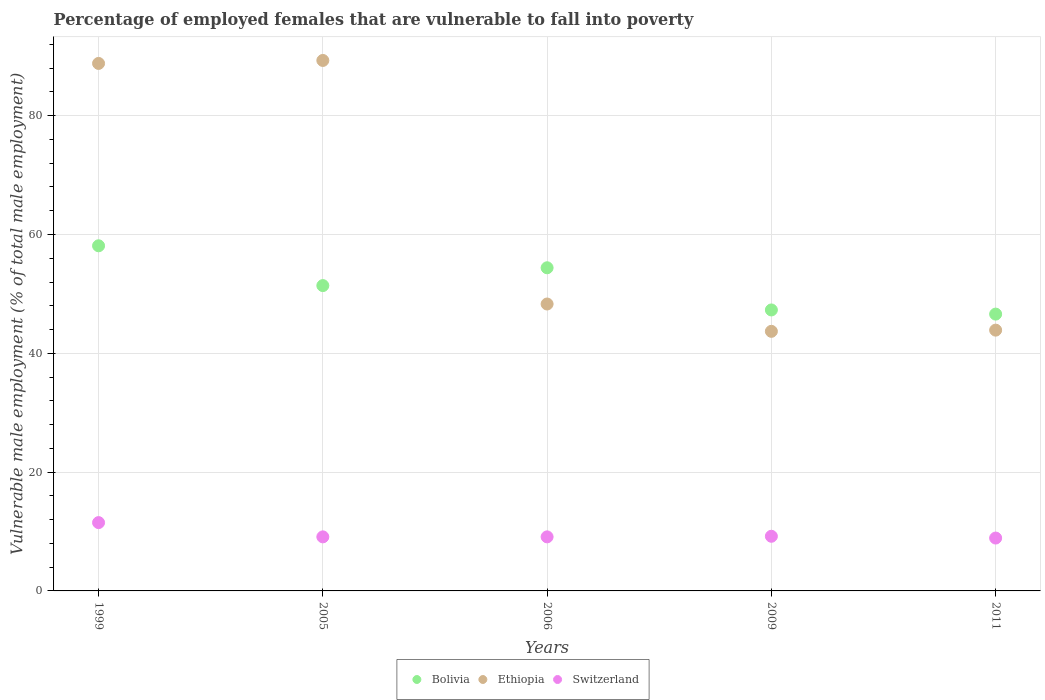What is the percentage of employed females who are vulnerable to fall into poverty in Bolivia in 1999?
Provide a short and direct response. 58.1. Across all years, what is the minimum percentage of employed females who are vulnerable to fall into poverty in Bolivia?
Your response must be concise. 46.6. What is the total percentage of employed females who are vulnerable to fall into poverty in Ethiopia in the graph?
Keep it short and to the point. 314. What is the difference between the percentage of employed females who are vulnerable to fall into poverty in Bolivia in 2005 and that in 2009?
Provide a short and direct response. 4.1. What is the difference between the percentage of employed females who are vulnerable to fall into poverty in Switzerland in 2006 and the percentage of employed females who are vulnerable to fall into poverty in Ethiopia in 2011?
Make the answer very short. -34.8. What is the average percentage of employed females who are vulnerable to fall into poverty in Bolivia per year?
Ensure brevity in your answer.  51.56. In the year 2005, what is the difference between the percentage of employed females who are vulnerable to fall into poverty in Bolivia and percentage of employed females who are vulnerable to fall into poverty in Ethiopia?
Make the answer very short. -37.9. What is the ratio of the percentage of employed females who are vulnerable to fall into poverty in Ethiopia in 1999 to that in 2005?
Your answer should be very brief. 0.99. Is the percentage of employed females who are vulnerable to fall into poverty in Ethiopia in 2005 less than that in 2009?
Provide a short and direct response. No. Is the difference between the percentage of employed females who are vulnerable to fall into poverty in Bolivia in 2006 and 2009 greater than the difference between the percentage of employed females who are vulnerable to fall into poverty in Ethiopia in 2006 and 2009?
Ensure brevity in your answer.  Yes. What is the difference between the highest and the second highest percentage of employed females who are vulnerable to fall into poverty in Bolivia?
Give a very brief answer. 3.7. What is the difference between the highest and the lowest percentage of employed females who are vulnerable to fall into poverty in Switzerland?
Provide a succinct answer. 2.6. How many dotlines are there?
Offer a very short reply. 3. How many years are there in the graph?
Provide a succinct answer. 5. Are the values on the major ticks of Y-axis written in scientific E-notation?
Your answer should be very brief. No. Does the graph contain any zero values?
Keep it short and to the point. No. What is the title of the graph?
Your response must be concise. Percentage of employed females that are vulnerable to fall into poverty. Does "Ethiopia" appear as one of the legend labels in the graph?
Keep it short and to the point. Yes. What is the label or title of the Y-axis?
Offer a very short reply. Vulnerable male employment (% of total male employment). What is the Vulnerable male employment (% of total male employment) of Bolivia in 1999?
Ensure brevity in your answer.  58.1. What is the Vulnerable male employment (% of total male employment) in Ethiopia in 1999?
Provide a succinct answer. 88.8. What is the Vulnerable male employment (% of total male employment) in Bolivia in 2005?
Keep it short and to the point. 51.4. What is the Vulnerable male employment (% of total male employment) in Ethiopia in 2005?
Your answer should be very brief. 89.3. What is the Vulnerable male employment (% of total male employment) of Switzerland in 2005?
Your answer should be compact. 9.1. What is the Vulnerable male employment (% of total male employment) in Bolivia in 2006?
Offer a very short reply. 54.4. What is the Vulnerable male employment (% of total male employment) in Ethiopia in 2006?
Your response must be concise. 48.3. What is the Vulnerable male employment (% of total male employment) of Switzerland in 2006?
Keep it short and to the point. 9.1. What is the Vulnerable male employment (% of total male employment) of Bolivia in 2009?
Make the answer very short. 47.3. What is the Vulnerable male employment (% of total male employment) of Ethiopia in 2009?
Offer a very short reply. 43.7. What is the Vulnerable male employment (% of total male employment) of Switzerland in 2009?
Make the answer very short. 9.2. What is the Vulnerable male employment (% of total male employment) in Bolivia in 2011?
Offer a terse response. 46.6. What is the Vulnerable male employment (% of total male employment) of Ethiopia in 2011?
Offer a very short reply. 43.9. What is the Vulnerable male employment (% of total male employment) in Switzerland in 2011?
Offer a very short reply. 8.9. Across all years, what is the maximum Vulnerable male employment (% of total male employment) in Bolivia?
Provide a short and direct response. 58.1. Across all years, what is the maximum Vulnerable male employment (% of total male employment) in Ethiopia?
Your response must be concise. 89.3. Across all years, what is the maximum Vulnerable male employment (% of total male employment) in Switzerland?
Keep it short and to the point. 11.5. Across all years, what is the minimum Vulnerable male employment (% of total male employment) of Bolivia?
Provide a succinct answer. 46.6. Across all years, what is the minimum Vulnerable male employment (% of total male employment) in Ethiopia?
Make the answer very short. 43.7. Across all years, what is the minimum Vulnerable male employment (% of total male employment) in Switzerland?
Provide a succinct answer. 8.9. What is the total Vulnerable male employment (% of total male employment) of Bolivia in the graph?
Your answer should be compact. 257.8. What is the total Vulnerable male employment (% of total male employment) in Ethiopia in the graph?
Make the answer very short. 314. What is the total Vulnerable male employment (% of total male employment) of Switzerland in the graph?
Give a very brief answer. 47.8. What is the difference between the Vulnerable male employment (% of total male employment) of Ethiopia in 1999 and that in 2006?
Keep it short and to the point. 40.5. What is the difference between the Vulnerable male employment (% of total male employment) in Ethiopia in 1999 and that in 2009?
Your answer should be compact. 45.1. What is the difference between the Vulnerable male employment (% of total male employment) of Bolivia in 1999 and that in 2011?
Your response must be concise. 11.5. What is the difference between the Vulnerable male employment (% of total male employment) of Ethiopia in 1999 and that in 2011?
Make the answer very short. 44.9. What is the difference between the Vulnerable male employment (% of total male employment) in Switzerland in 1999 and that in 2011?
Give a very brief answer. 2.6. What is the difference between the Vulnerable male employment (% of total male employment) in Ethiopia in 2005 and that in 2006?
Keep it short and to the point. 41. What is the difference between the Vulnerable male employment (% of total male employment) of Bolivia in 2005 and that in 2009?
Your response must be concise. 4.1. What is the difference between the Vulnerable male employment (% of total male employment) of Ethiopia in 2005 and that in 2009?
Your answer should be very brief. 45.6. What is the difference between the Vulnerable male employment (% of total male employment) in Switzerland in 2005 and that in 2009?
Provide a succinct answer. -0.1. What is the difference between the Vulnerable male employment (% of total male employment) of Ethiopia in 2005 and that in 2011?
Your response must be concise. 45.4. What is the difference between the Vulnerable male employment (% of total male employment) in Switzerland in 2005 and that in 2011?
Offer a very short reply. 0.2. What is the difference between the Vulnerable male employment (% of total male employment) in Bolivia in 2006 and that in 2009?
Make the answer very short. 7.1. What is the difference between the Vulnerable male employment (% of total male employment) in Ethiopia in 2006 and that in 2009?
Provide a succinct answer. 4.6. What is the difference between the Vulnerable male employment (% of total male employment) of Ethiopia in 2006 and that in 2011?
Make the answer very short. 4.4. What is the difference between the Vulnerable male employment (% of total male employment) in Bolivia in 2009 and that in 2011?
Offer a terse response. 0.7. What is the difference between the Vulnerable male employment (% of total male employment) of Switzerland in 2009 and that in 2011?
Give a very brief answer. 0.3. What is the difference between the Vulnerable male employment (% of total male employment) of Bolivia in 1999 and the Vulnerable male employment (% of total male employment) of Ethiopia in 2005?
Provide a short and direct response. -31.2. What is the difference between the Vulnerable male employment (% of total male employment) of Ethiopia in 1999 and the Vulnerable male employment (% of total male employment) of Switzerland in 2005?
Offer a very short reply. 79.7. What is the difference between the Vulnerable male employment (% of total male employment) in Ethiopia in 1999 and the Vulnerable male employment (% of total male employment) in Switzerland in 2006?
Give a very brief answer. 79.7. What is the difference between the Vulnerable male employment (% of total male employment) in Bolivia in 1999 and the Vulnerable male employment (% of total male employment) in Switzerland in 2009?
Give a very brief answer. 48.9. What is the difference between the Vulnerable male employment (% of total male employment) of Ethiopia in 1999 and the Vulnerable male employment (% of total male employment) of Switzerland in 2009?
Keep it short and to the point. 79.6. What is the difference between the Vulnerable male employment (% of total male employment) of Bolivia in 1999 and the Vulnerable male employment (% of total male employment) of Switzerland in 2011?
Offer a terse response. 49.2. What is the difference between the Vulnerable male employment (% of total male employment) in Ethiopia in 1999 and the Vulnerable male employment (% of total male employment) in Switzerland in 2011?
Keep it short and to the point. 79.9. What is the difference between the Vulnerable male employment (% of total male employment) of Bolivia in 2005 and the Vulnerable male employment (% of total male employment) of Switzerland in 2006?
Give a very brief answer. 42.3. What is the difference between the Vulnerable male employment (% of total male employment) of Ethiopia in 2005 and the Vulnerable male employment (% of total male employment) of Switzerland in 2006?
Your response must be concise. 80.2. What is the difference between the Vulnerable male employment (% of total male employment) in Bolivia in 2005 and the Vulnerable male employment (% of total male employment) in Ethiopia in 2009?
Keep it short and to the point. 7.7. What is the difference between the Vulnerable male employment (% of total male employment) of Bolivia in 2005 and the Vulnerable male employment (% of total male employment) of Switzerland in 2009?
Provide a short and direct response. 42.2. What is the difference between the Vulnerable male employment (% of total male employment) of Ethiopia in 2005 and the Vulnerable male employment (% of total male employment) of Switzerland in 2009?
Keep it short and to the point. 80.1. What is the difference between the Vulnerable male employment (% of total male employment) in Bolivia in 2005 and the Vulnerable male employment (% of total male employment) in Switzerland in 2011?
Your answer should be very brief. 42.5. What is the difference between the Vulnerable male employment (% of total male employment) in Ethiopia in 2005 and the Vulnerable male employment (% of total male employment) in Switzerland in 2011?
Offer a very short reply. 80.4. What is the difference between the Vulnerable male employment (% of total male employment) of Bolivia in 2006 and the Vulnerable male employment (% of total male employment) of Ethiopia in 2009?
Ensure brevity in your answer.  10.7. What is the difference between the Vulnerable male employment (% of total male employment) in Bolivia in 2006 and the Vulnerable male employment (% of total male employment) in Switzerland in 2009?
Give a very brief answer. 45.2. What is the difference between the Vulnerable male employment (% of total male employment) of Ethiopia in 2006 and the Vulnerable male employment (% of total male employment) of Switzerland in 2009?
Make the answer very short. 39.1. What is the difference between the Vulnerable male employment (% of total male employment) in Bolivia in 2006 and the Vulnerable male employment (% of total male employment) in Ethiopia in 2011?
Keep it short and to the point. 10.5. What is the difference between the Vulnerable male employment (% of total male employment) of Bolivia in 2006 and the Vulnerable male employment (% of total male employment) of Switzerland in 2011?
Make the answer very short. 45.5. What is the difference between the Vulnerable male employment (% of total male employment) in Ethiopia in 2006 and the Vulnerable male employment (% of total male employment) in Switzerland in 2011?
Offer a terse response. 39.4. What is the difference between the Vulnerable male employment (% of total male employment) in Bolivia in 2009 and the Vulnerable male employment (% of total male employment) in Switzerland in 2011?
Offer a terse response. 38.4. What is the difference between the Vulnerable male employment (% of total male employment) in Ethiopia in 2009 and the Vulnerable male employment (% of total male employment) in Switzerland in 2011?
Offer a very short reply. 34.8. What is the average Vulnerable male employment (% of total male employment) of Bolivia per year?
Provide a short and direct response. 51.56. What is the average Vulnerable male employment (% of total male employment) of Ethiopia per year?
Your answer should be compact. 62.8. What is the average Vulnerable male employment (% of total male employment) of Switzerland per year?
Provide a succinct answer. 9.56. In the year 1999, what is the difference between the Vulnerable male employment (% of total male employment) of Bolivia and Vulnerable male employment (% of total male employment) of Ethiopia?
Provide a succinct answer. -30.7. In the year 1999, what is the difference between the Vulnerable male employment (% of total male employment) of Bolivia and Vulnerable male employment (% of total male employment) of Switzerland?
Make the answer very short. 46.6. In the year 1999, what is the difference between the Vulnerable male employment (% of total male employment) of Ethiopia and Vulnerable male employment (% of total male employment) of Switzerland?
Your answer should be compact. 77.3. In the year 2005, what is the difference between the Vulnerable male employment (% of total male employment) of Bolivia and Vulnerable male employment (% of total male employment) of Ethiopia?
Offer a very short reply. -37.9. In the year 2005, what is the difference between the Vulnerable male employment (% of total male employment) in Bolivia and Vulnerable male employment (% of total male employment) in Switzerland?
Keep it short and to the point. 42.3. In the year 2005, what is the difference between the Vulnerable male employment (% of total male employment) in Ethiopia and Vulnerable male employment (% of total male employment) in Switzerland?
Give a very brief answer. 80.2. In the year 2006, what is the difference between the Vulnerable male employment (% of total male employment) of Bolivia and Vulnerable male employment (% of total male employment) of Ethiopia?
Offer a very short reply. 6.1. In the year 2006, what is the difference between the Vulnerable male employment (% of total male employment) in Bolivia and Vulnerable male employment (% of total male employment) in Switzerland?
Ensure brevity in your answer.  45.3. In the year 2006, what is the difference between the Vulnerable male employment (% of total male employment) of Ethiopia and Vulnerable male employment (% of total male employment) of Switzerland?
Give a very brief answer. 39.2. In the year 2009, what is the difference between the Vulnerable male employment (% of total male employment) of Bolivia and Vulnerable male employment (% of total male employment) of Switzerland?
Make the answer very short. 38.1. In the year 2009, what is the difference between the Vulnerable male employment (% of total male employment) of Ethiopia and Vulnerable male employment (% of total male employment) of Switzerland?
Provide a short and direct response. 34.5. In the year 2011, what is the difference between the Vulnerable male employment (% of total male employment) in Bolivia and Vulnerable male employment (% of total male employment) in Ethiopia?
Ensure brevity in your answer.  2.7. In the year 2011, what is the difference between the Vulnerable male employment (% of total male employment) in Bolivia and Vulnerable male employment (% of total male employment) in Switzerland?
Give a very brief answer. 37.7. In the year 2011, what is the difference between the Vulnerable male employment (% of total male employment) of Ethiopia and Vulnerable male employment (% of total male employment) of Switzerland?
Provide a short and direct response. 35. What is the ratio of the Vulnerable male employment (% of total male employment) in Bolivia in 1999 to that in 2005?
Give a very brief answer. 1.13. What is the ratio of the Vulnerable male employment (% of total male employment) of Ethiopia in 1999 to that in 2005?
Provide a short and direct response. 0.99. What is the ratio of the Vulnerable male employment (% of total male employment) in Switzerland in 1999 to that in 2005?
Make the answer very short. 1.26. What is the ratio of the Vulnerable male employment (% of total male employment) in Bolivia in 1999 to that in 2006?
Make the answer very short. 1.07. What is the ratio of the Vulnerable male employment (% of total male employment) in Ethiopia in 1999 to that in 2006?
Your response must be concise. 1.84. What is the ratio of the Vulnerable male employment (% of total male employment) of Switzerland in 1999 to that in 2006?
Give a very brief answer. 1.26. What is the ratio of the Vulnerable male employment (% of total male employment) of Bolivia in 1999 to that in 2009?
Ensure brevity in your answer.  1.23. What is the ratio of the Vulnerable male employment (% of total male employment) of Ethiopia in 1999 to that in 2009?
Keep it short and to the point. 2.03. What is the ratio of the Vulnerable male employment (% of total male employment) in Bolivia in 1999 to that in 2011?
Your response must be concise. 1.25. What is the ratio of the Vulnerable male employment (% of total male employment) of Ethiopia in 1999 to that in 2011?
Keep it short and to the point. 2.02. What is the ratio of the Vulnerable male employment (% of total male employment) of Switzerland in 1999 to that in 2011?
Your answer should be very brief. 1.29. What is the ratio of the Vulnerable male employment (% of total male employment) of Bolivia in 2005 to that in 2006?
Your answer should be very brief. 0.94. What is the ratio of the Vulnerable male employment (% of total male employment) in Ethiopia in 2005 to that in 2006?
Your answer should be very brief. 1.85. What is the ratio of the Vulnerable male employment (% of total male employment) in Bolivia in 2005 to that in 2009?
Ensure brevity in your answer.  1.09. What is the ratio of the Vulnerable male employment (% of total male employment) of Ethiopia in 2005 to that in 2009?
Your response must be concise. 2.04. What is the ratio of the Vulnerable male employment (% of total male employment) of Bolivia in 2005 to that in 2011?
Provide a short and direct response. 1.1. What is the ratio of the Vulnerable male employment (% of total male employment) of Ethiopia in 2005 to that in 2011?
Offer a terse response. 2.03. What is the ratio of the Vulnerable male employment (% of total male employment) of Switzerland in 2005 to that in 2011?
Provide a succinct answer. 1.02. What is the ratio of the Vulnerable male employment (% of total male employment) in Bolivia in 2006 to that in 2009?
Ensure brevity in your answer.  1.15. What is the ratio of the Vulnerable male employment (% of total male employment) of Ethiopia in 2006 to that in 2009?
Make the answer very short. 1.11. What is the ratio of the Vulnerable male employment (% of total male employment) in Switzerland in 2006 to that in 2009?
Your response must be concise. 0.99. What is the ratio of the Vulnerable male employment (% of total male employment) of Bolivia in 2006 to that in 2011?
Your response must be concise. 1.17. What is the ratio of the Vulnerable male employment (% of total male employment) of Ethiopia in 2006 to that in 2011?
Provide a succinct answer. 1.1. What is the ratio of the Vulnerable male employment (% of total male employment) of Switzerland in 2006 to that in 2011?
Provide a short and direct response. 1.02. What is the ratio of the Vulnerable male employment (% of total male employment) of Bolivia in 2009 to that in 2011?
Your answer should be very brief. 1.01. What is the ratio of the Vulnerable male employment (% of total male employment) of Ethiopia in 2009 to that in 2011?
Keep it short and to the point. 1. What is the ratio of the Vulnerable male employment (% of total male employment) in Switzerland in 2009 to that in 2011?
Offer a terse response. 1.03. What is the difference between the highest and the second highest Vulnerable male employment (% of total male employment) of Bolivia?
Your response must be concise. 3.7. What is the difference between the highest and the second highest Vulnerable male employment (% of total male employment) of Ethiopia?
Provide a short and direct response. 0.5. What is the difference between the highest and the second highest Vulnerable male employment (% of total male employment) of Switzerland?
Give a very brief answer. 2.3. What is the difference between the highest and the lowest Vulnerable male employment (% of total male employment) in Bolivia?
Ensure brevity in your answer.  11.5. What is the difference between the highest and the lowest Vulnerable male employment (% of total male employment) of Ethiopia?
Make the answer very short. 45.6. 